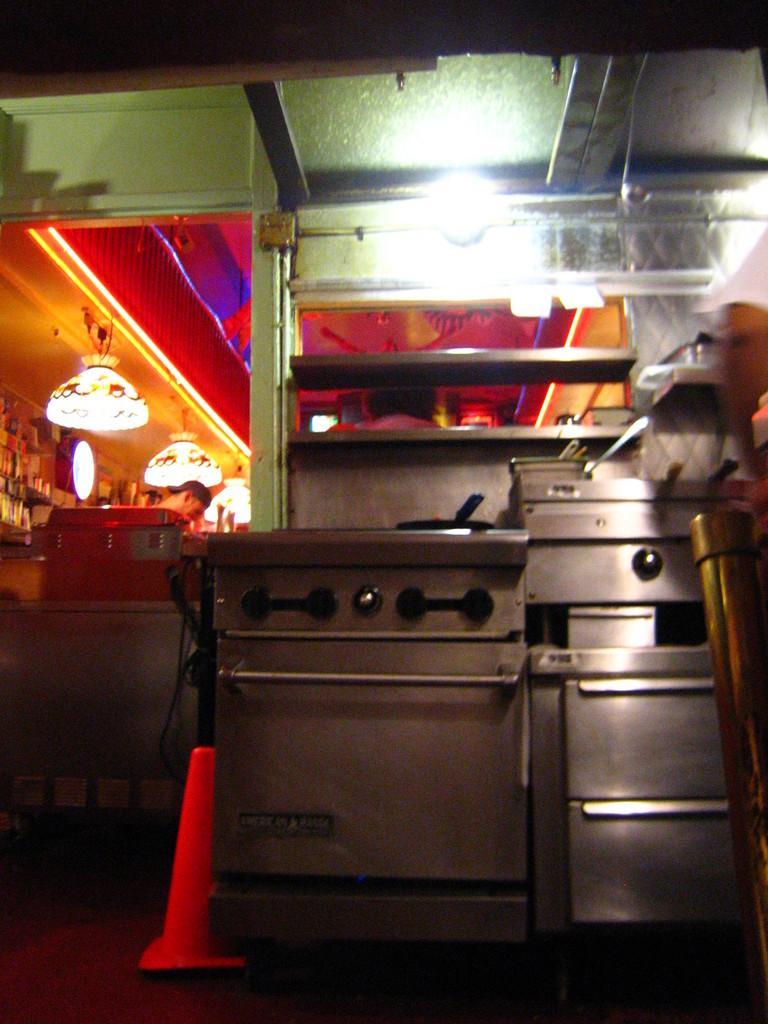How would you summarize this image in a sentence or two? In this picture we can see a person. There are boxes on the table. We can see a few lights on top. There is a pan on a surface. 